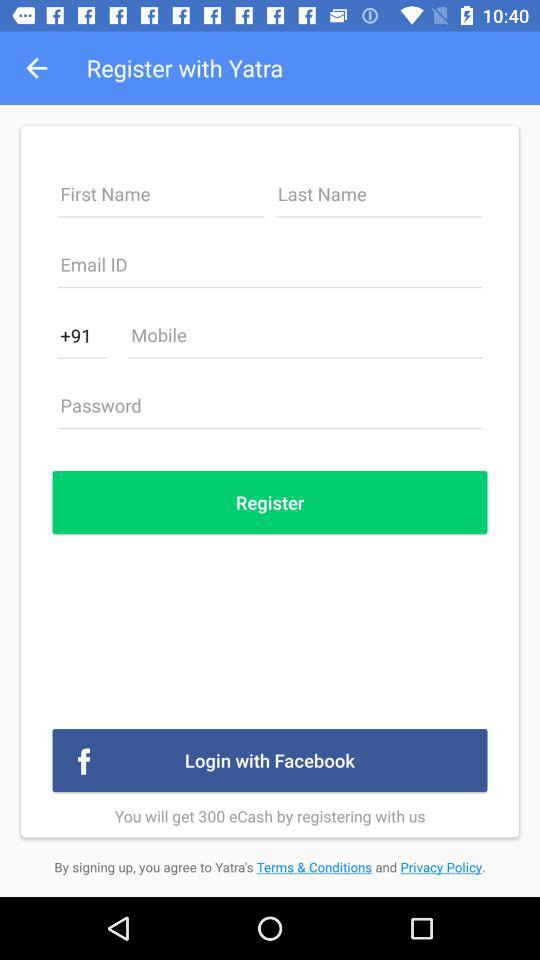How much eCash can we get by registering? You can get 300 eCash by registering. 